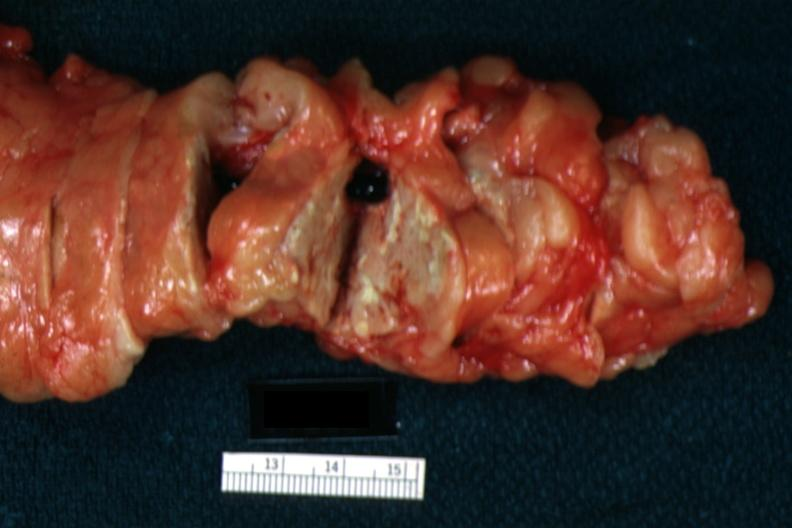does this image show fat necrosis well seen with no evident parenchymal lesion?
Answer the question using a single word or phrase. Yes 